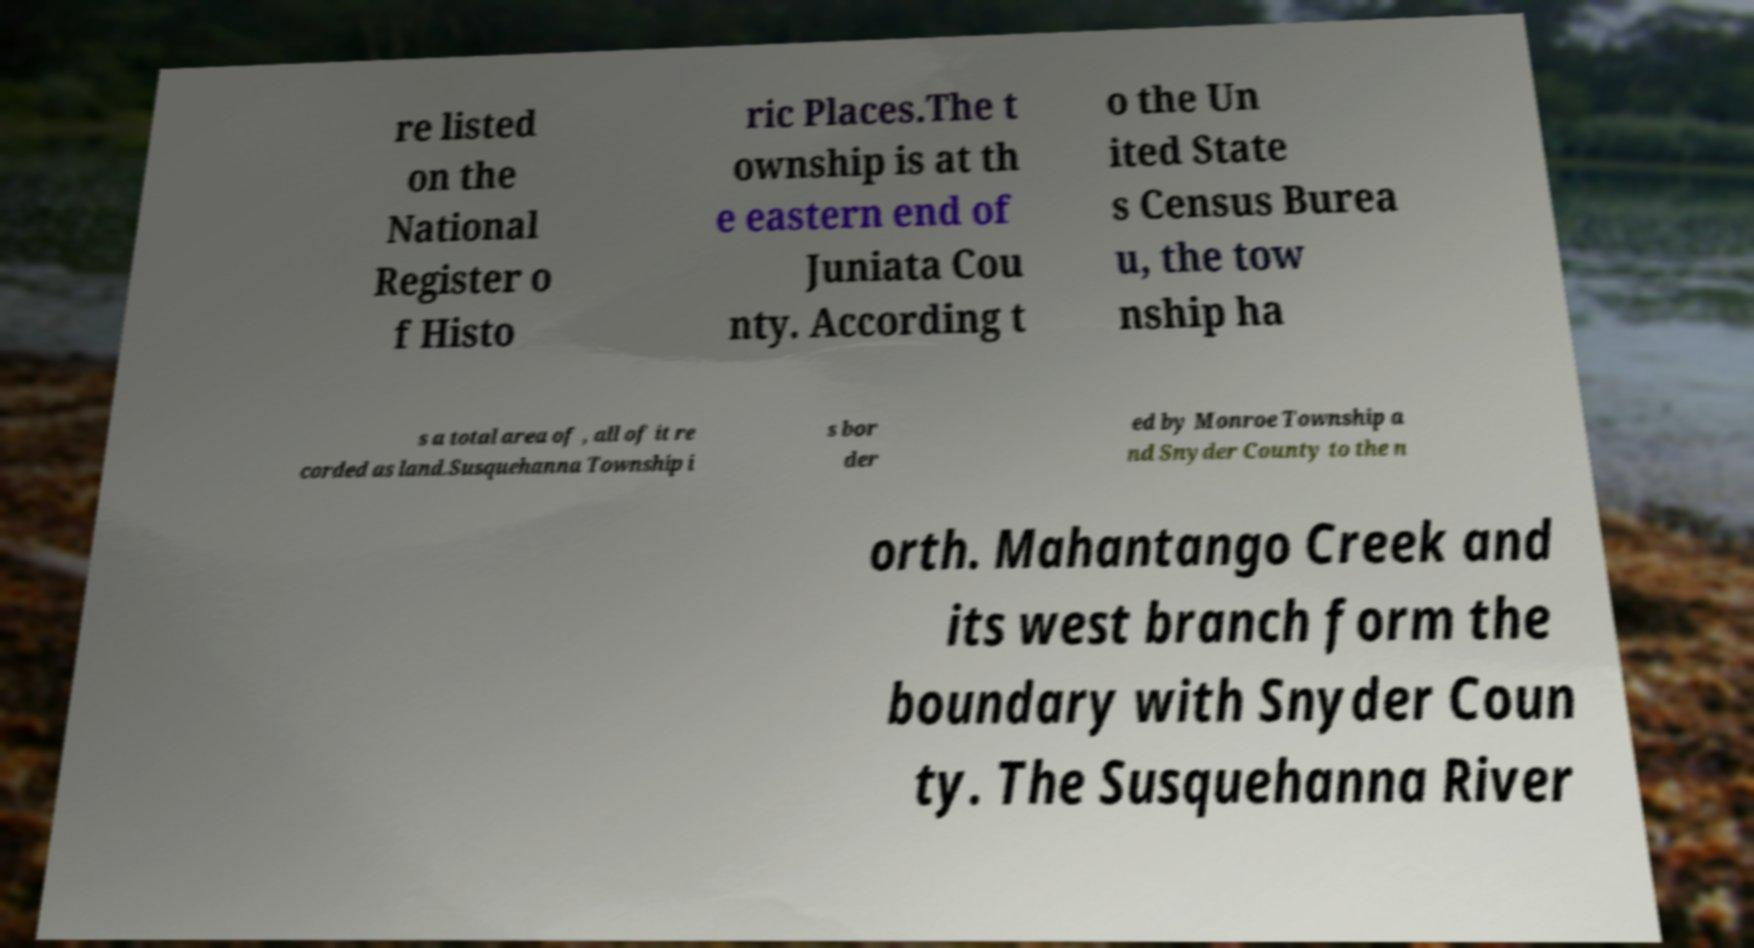There's text embedded in this image that I need extracted. Can you transcribe it verbatim? re listed on the National Register o f Histo ric Places.The t ownship is at th e eastern end of Juniata Cou nty. According t o the Un ited State s Census Burea u, the tow nship ha s a total area of , all of it re corded as land.Susquehanna Township i s bor der ed by Monroe Township a nd Snyder County to the n orth. Mahantango Creek and its west branch form the boundary with Snyder Coun ty. The Susquehanna River 